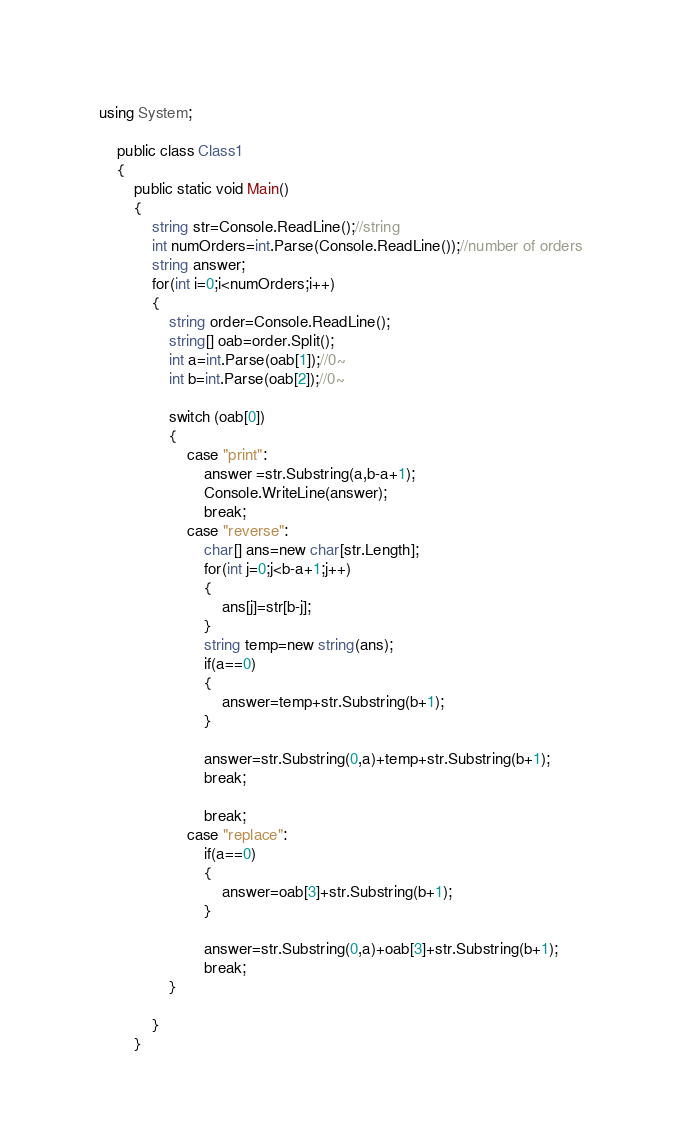Convert code to text. <code><loc_0><loc_0><loc_500><loc_500><_C#_>
using System;

	public class Class1
	{
		public static void Main()
		{  
			string str=Console.ReadLine();//string
			int numOrders=int.Parse(Console.ReadLine());//number of orders
			string answer;
			for(int i=0;i<numOrders;i++)
			{
				string order=Console.ReadLine();
				string[] oab=order.Split();
				int a=int.Parse(oab[1]);//0~
				int b=int.Parse(oab[2]);//0~
				
				switch (oab[0])
				{
					case "print":
						answer =str.Substring(a,b-a+1);
						Console.WriteLine(answer);
						break;
					case "reverse":
						char[] ans=new char[str.Length];
						for(int j=0;j<b-a+1;j++)
						{							
							ans[j]=str[b-j];
						}
						string temp=new string(ans);
						if(a==0)
						{
							answer=temp+str.Substring(b+1);
						}
											
						answer=str.Substring(0,a)+temp+str.Substring(b+1);
						break;
						
						break;
					case "replace":
						if(a==0)
						{
							answer=oab[3]+str.Substring(b+1);
						}
											
						answer=str.Substring(0,a)+oab[3]+str.Substring(b+1);
						break;
				}
					
			}
		}</code> 